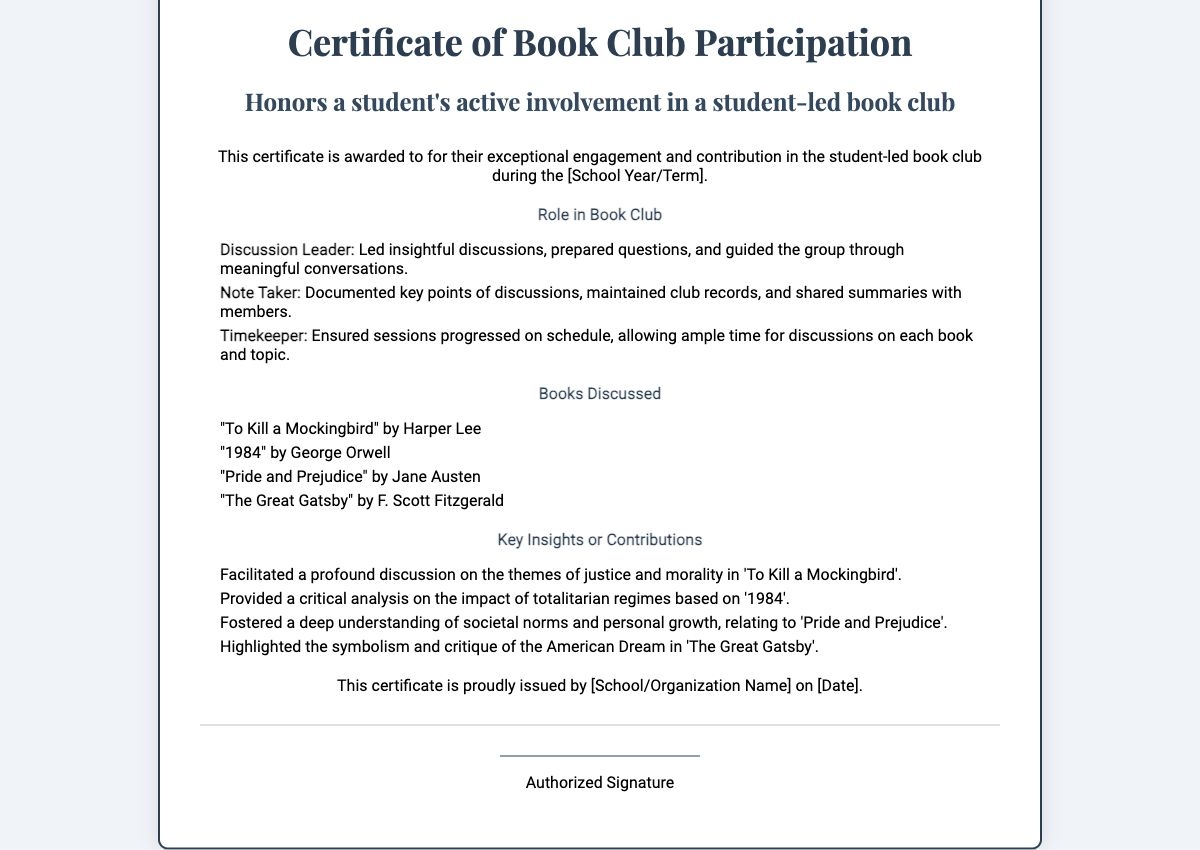What is the title of the certificate? The title of the certificate is mentioned at the top of the document.
Answer: Certificate of Book Club Participation Who is the certificate awarded to? The name of the student is indicated on the certificate and is specified at the top.
Answer: [Student Name] What roles are listed in the book club participation? The document lists various roles that the student may have taken in the book club.
Answer: Discussion Leader, Note Taker, Timekeeper How many books were discussed in the book club? The document indicates the number of books mentioned under the "Books Discussed" section.
Answer: Four Which book by Harper Lee was discussed? The document lists specific titles and their authors under the "Books Discussed" section.
Answer: To Kill a Mockingbird What insight was provided regarding '1984'? The document specifies a key insight related to this book in the "Key Insights or Contributions" section.
Answer: Provided a critical analysis on the impact of totalitarian regimes What organization issued this certificate? The name of the issuing school or organization is provided at the end of the document.
Answer: [School/Organization Name] When was the certificate issued? The date of issuance is mentioned near the end of the certificate.
Answer: [Date] 